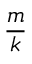<formula> <loc_0><loc_0><loc_500><loc_500>\frac { m } { k }</formula> 